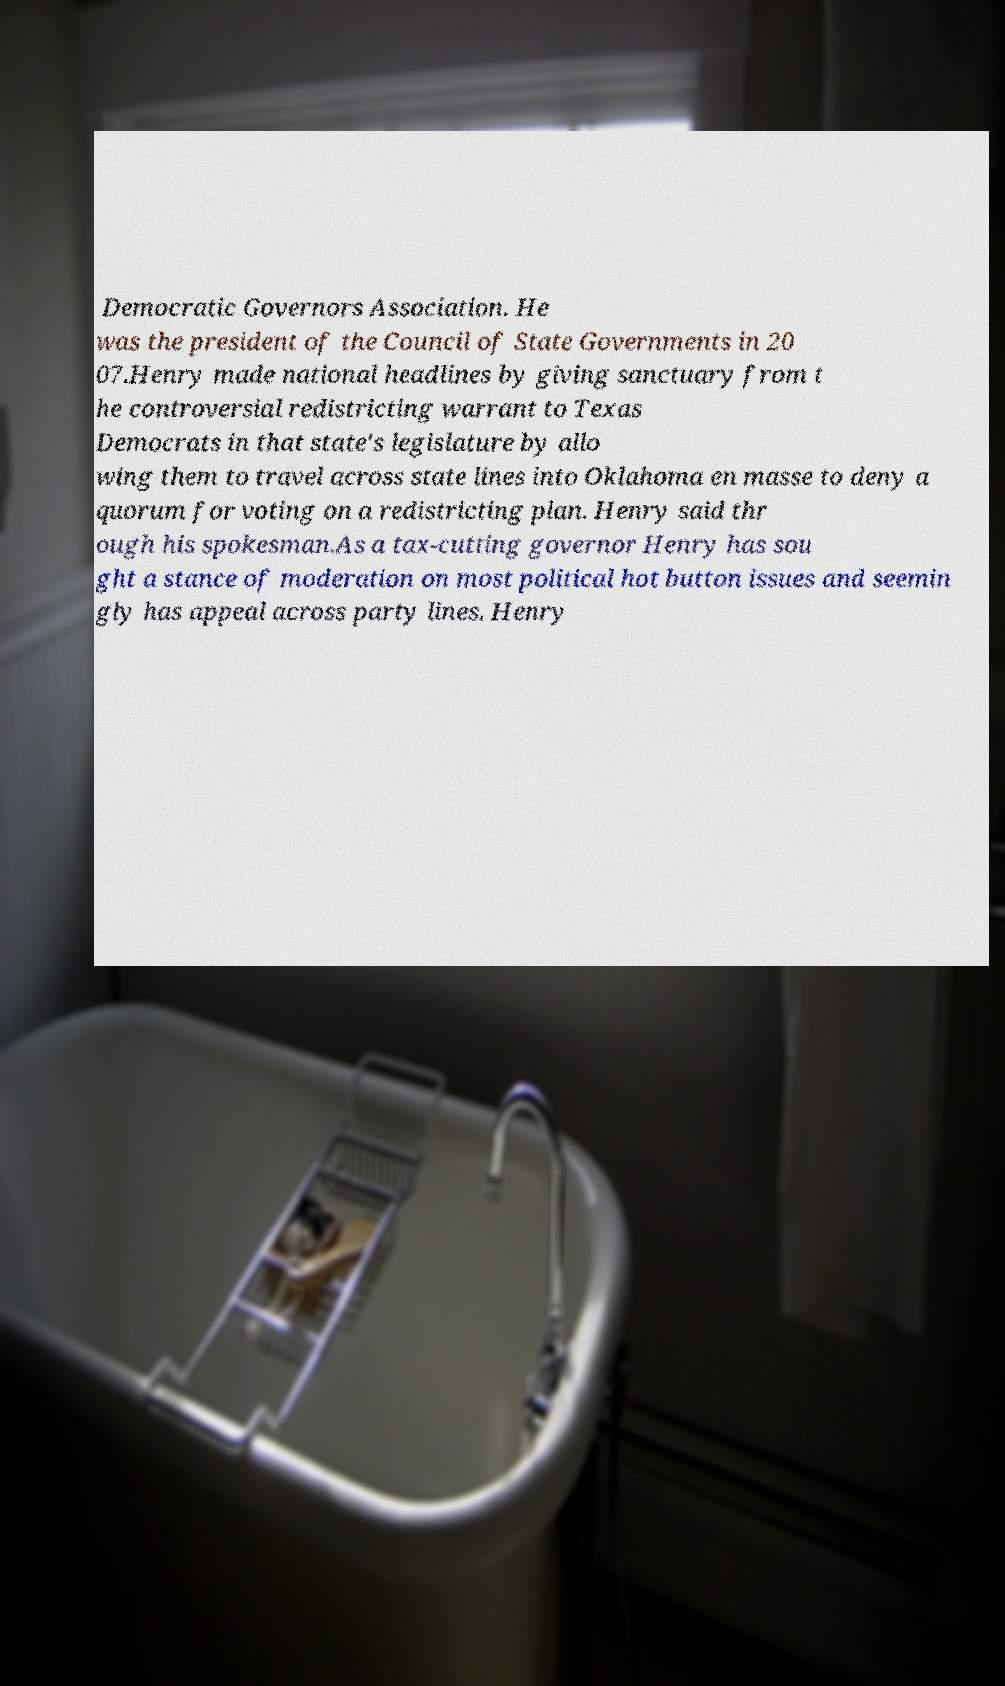Can you read and provide the text displayed in the image?This photo seems to have some interesting text. Can you extract and type it out for me? Democratic Governors Association. He was the president of the Council of State Governments in 20 07.Henry made national headlines by giving sanctuary from t he controversial redistricting warrant to Texas Democrats in that state's legislature by allo wing them to travel across state lines into Oklahoma en masse to deny a quorum for voting on a redistricting plan. Henry said thr ough his spokesman.As a tax-cutting governor Henry has sou ght a stance of moderation on most political hot button issues and seemin gly has appeal across party lines. Henry 